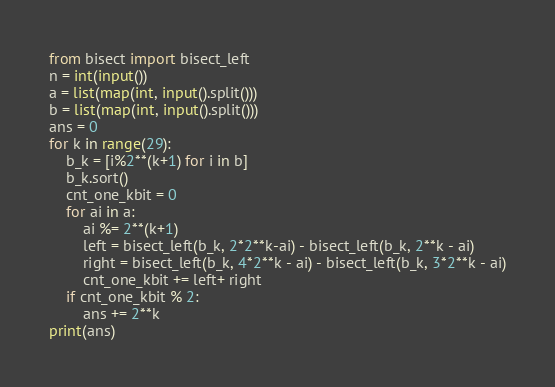<code> <loc_0><loc_0><loc_500><loc_500><_Python_>from bisect import bisect_left
n = int(input())
a = list(map(int, input().split()))
b = list(map(int, input().split()))
ans = 0
for k in range(29):
    b_k = [i%2**(k+1) for i in b]
    b_k.sort()
    cnt_one_kbit = 0
    for ai in a:
        ai %= 2**(k+1)
        left = bisect_left(b_k, 2*2**k-ai) - bisect_left(b_k, 2**k - ai)
        right = bisect_left(b_k, 4*2**k - ai) - bisect_left(b_k, 3*2**k - ai)
        cnt_one_kbit += left+ right
    if cnt_one_kbit % 2:
        ans += 2**k
print(ans)</code> 